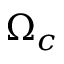<formula> <loc_0><loc_0><loc_500><loc_500>\Omega _ { c }</formula> 